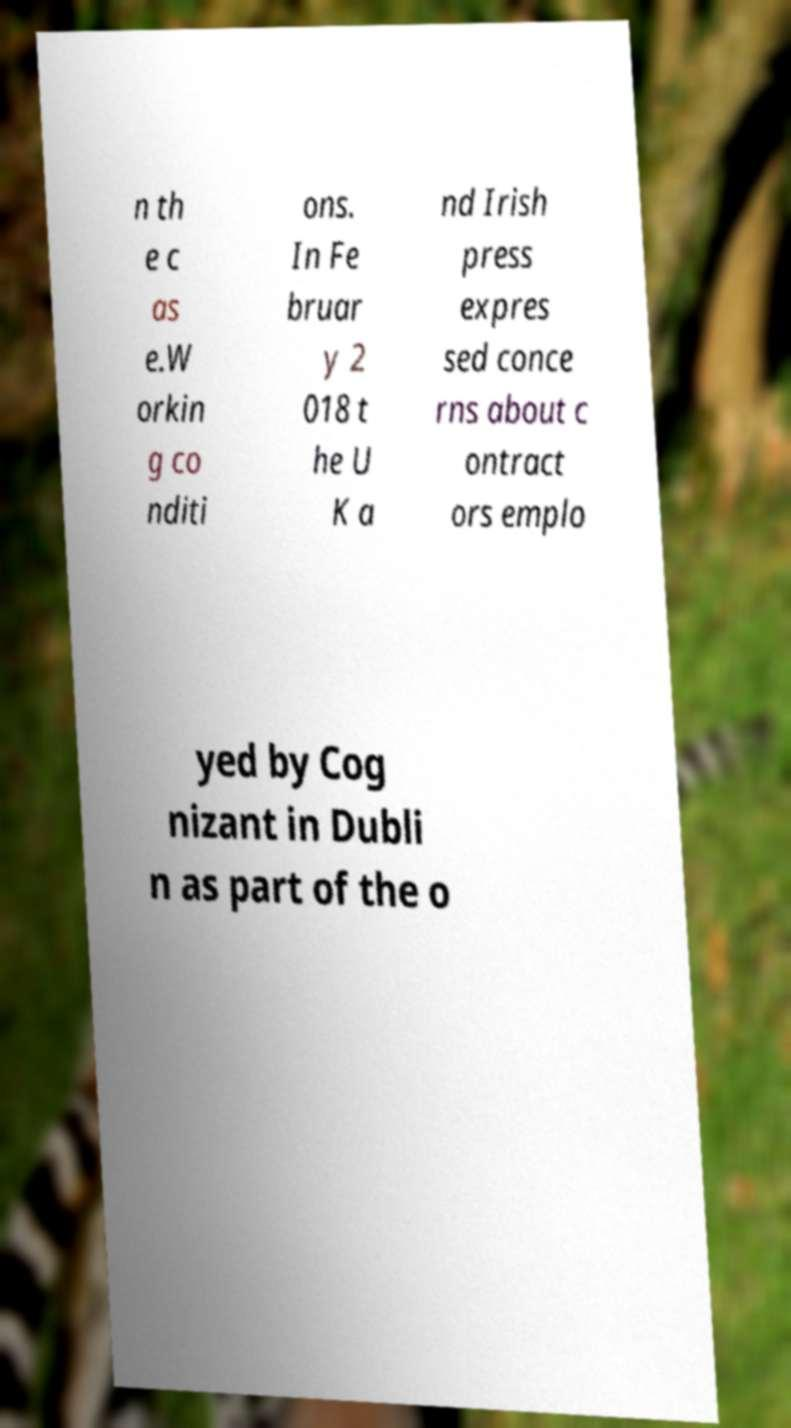Please read and relay the text visible in this image. What does it say? n th e c as e.W orkin g co nditi ons. In Fe bruar y 2 018 t he U K a nd Irish press expres sed conce rns about c ontract ors emplo yed by Cog nizant in Dubli n as part of the o 